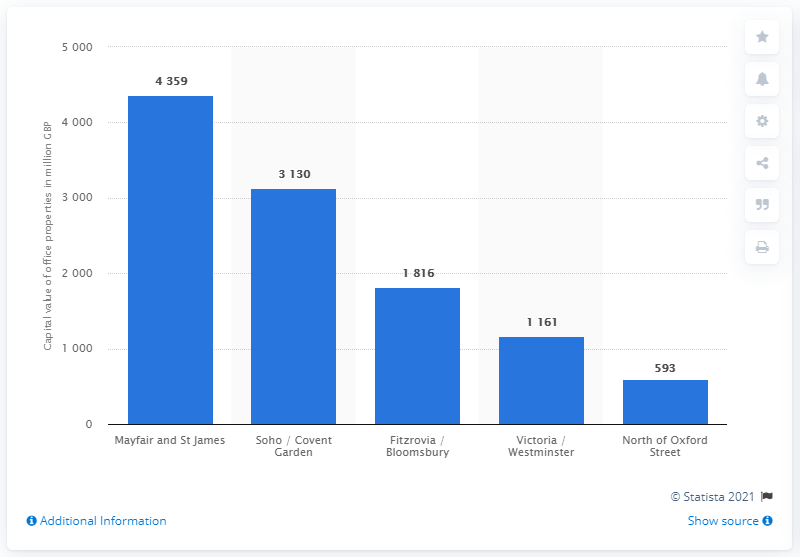Identify some key points in this picture. In 2014, the total amount of Mayfair and St. James's assets was 4,359... 